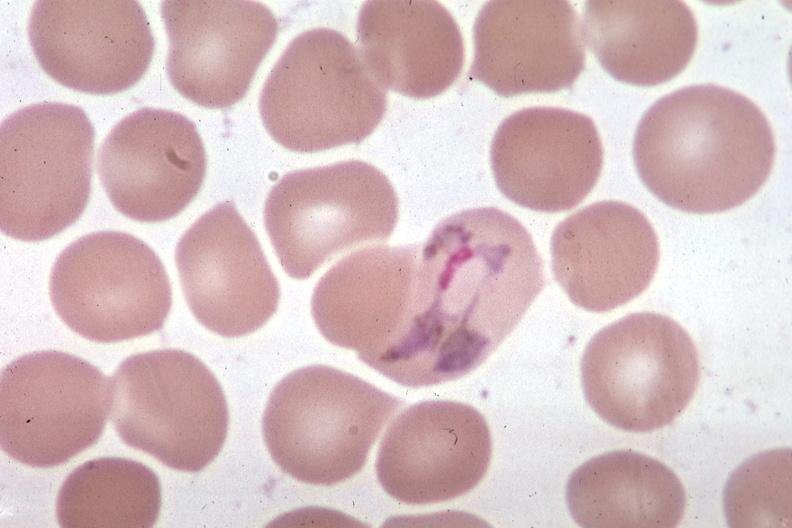what is present?
Answer the question using a single word or phrase. Blood 